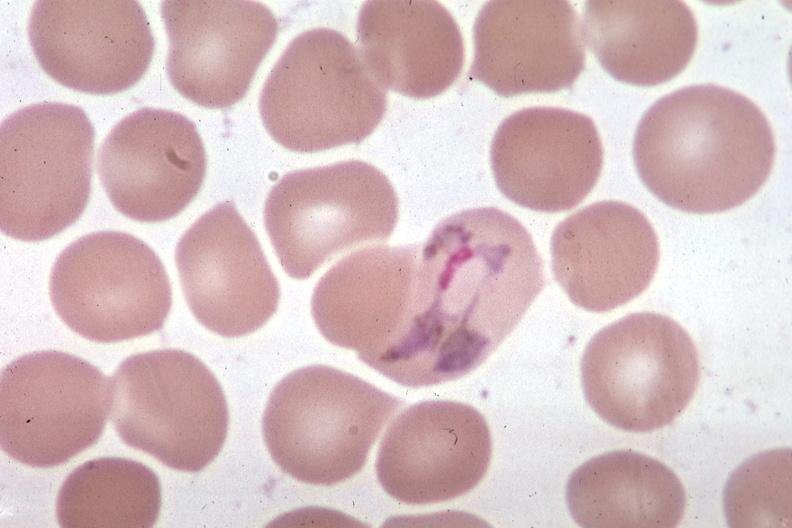what is present?
Answer the question using a single word or phrase. Blood 